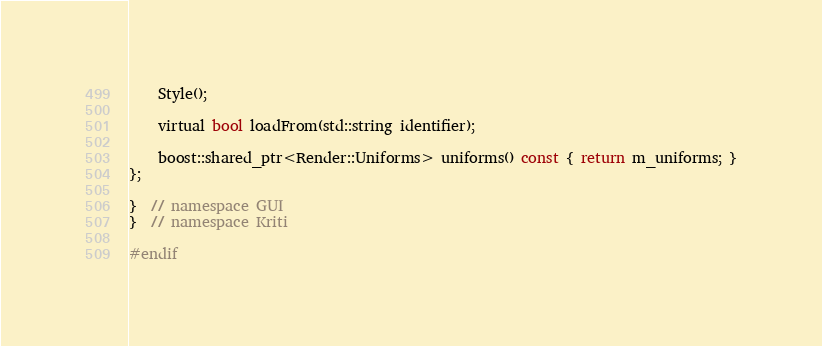Convert code to text. <code><loc_0><loc_0><loc_500><loc_500><_C_>    Style();

    virtual bool loadFrom(std::string identifier);

    boost::shared_ptr<Render::Uniforms> uniforms() const { return m_uniforms; }
};

}  // namespace GUI
}  // namespace Kriti

#endif
</code> 